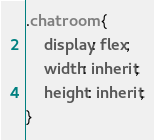Convert code to text. <code><loc_0><loc_0><loc_500><loc_500><_CSS_>.chatroom {
    display: flex;
    width: inherit;
    height: inherit;
}</code> 